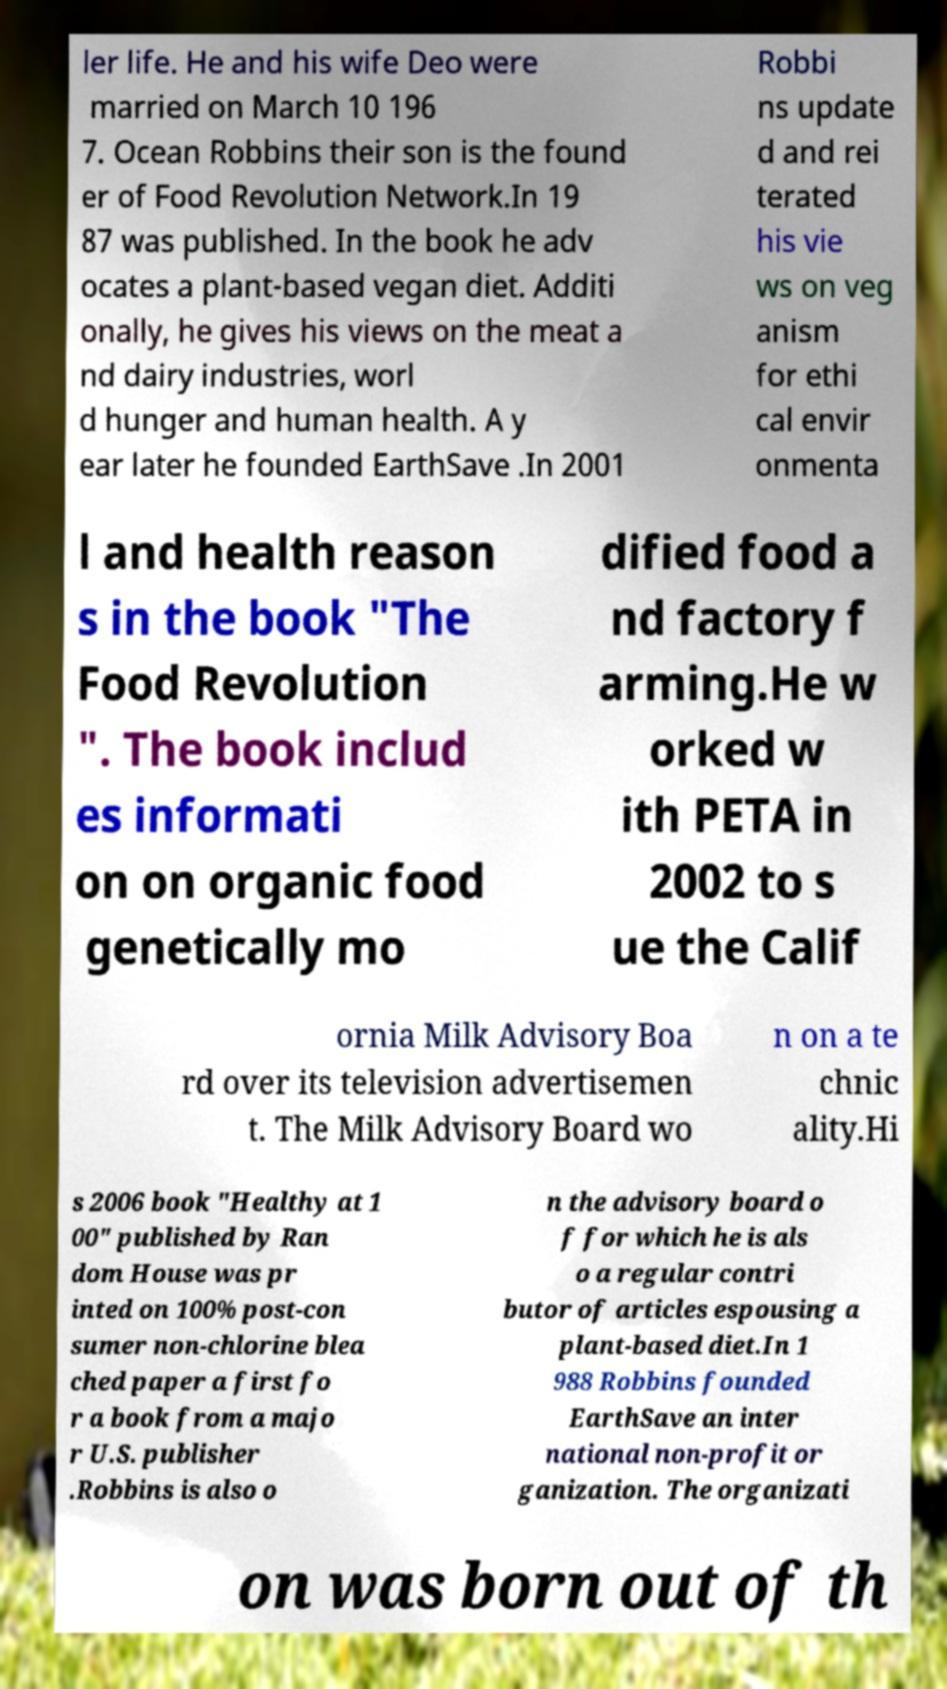For documentation purposes, I need the text within this image transcribed. Could you provide that? ler life. He and his wife Deo were married on March 10 196 7. Ocean Robbins their son is the found er of Food Revolution Network.In 19 87 was published. In the book he adv ocates a plant-based vegan diet. Additi onally, he gives his views on the meat a nd dairy industries, worl d hunger and human health. A y ear later he founded EarthSave .In 2001 Robbi ns update d and rei terated his vie ws on veg anism for ethi cal envir onmenta l and health reason s in the book "The Food Revolution ". The book includ es informati on on organic food genetically mo dified food a nd factory f arming.He w orked w ith PETA in 2002 to s ue the Calif ornia Milk Advisory Boa rd over its television advertisemen t. The Milk Advisory Board wo n on a te chnic ality.Hi s 2006 book "Healthy at 1 00" published by Ran dom House was pr inted on 100% post-con sumer non-chlorine blea ched paper a first fo r a book from a majo r U.S. publisher .Robbins is also o n the advisory board o f for which he is als o a regular contri butor of articles espousing a plant-based diet.In 1 988 Robbins founded EarthSave an inter national non-profit or ganization. The organizati on was born out of th 